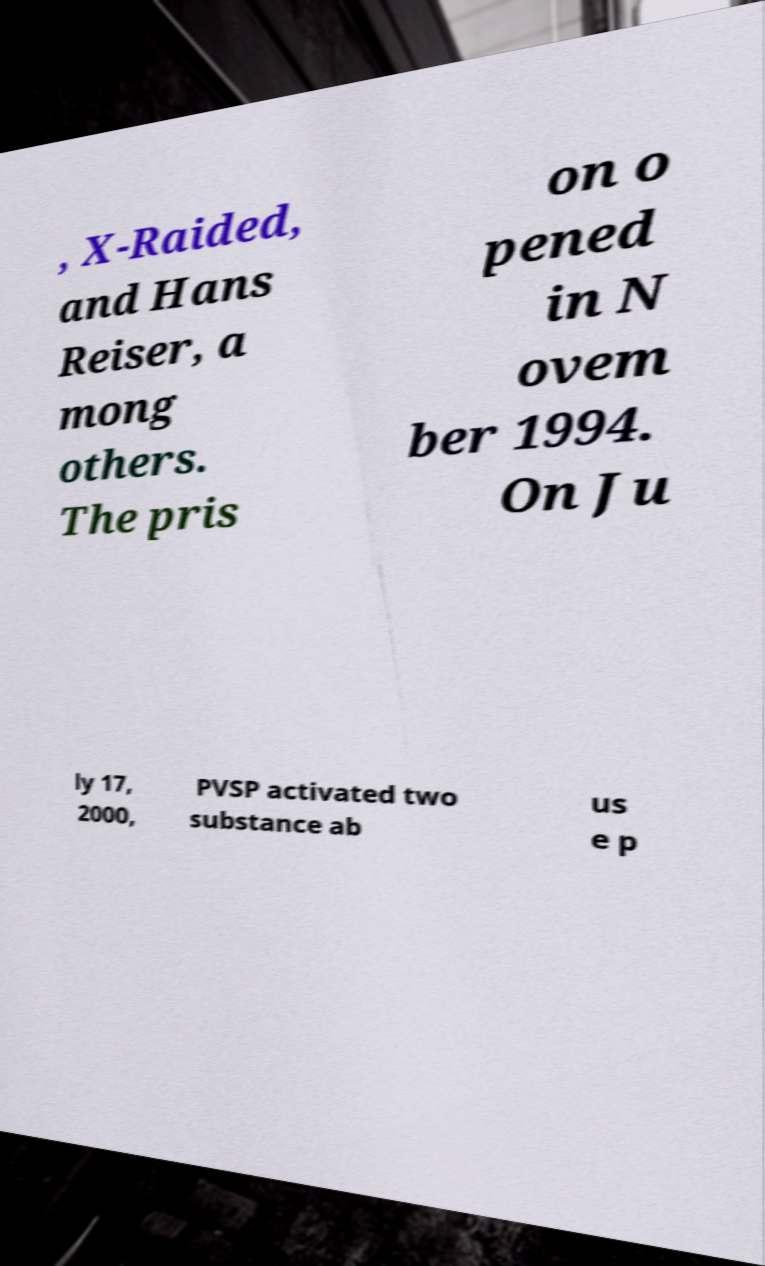Please identify and transcribe the text found in this image. , X-Raided, and Hans Reiser, a mong others. The pris on o pened in N ovem ber 1994. On Ju ly 17, 2000, PVSP activated two substance ab us e p 